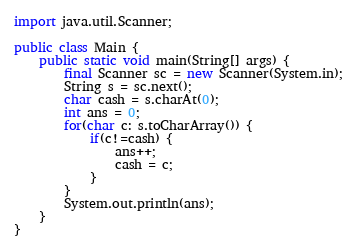<code> <loc_0><loc_0><loc_500><loc_500><_Java_>import java.util.Scanner;

public class Main {
	public static void main(String[] args) {
		final Scanner sc = new Scanner(System.in);
		String s = sc.next();
		char cash = s.charAt(0);
		int ans = 0;
		for(char c: s.toCharArray()) {
			if(c!=cash) {
				ans++;
				cash = c;
			}
		}
		System.out.println(ans);
	}
}</code> 